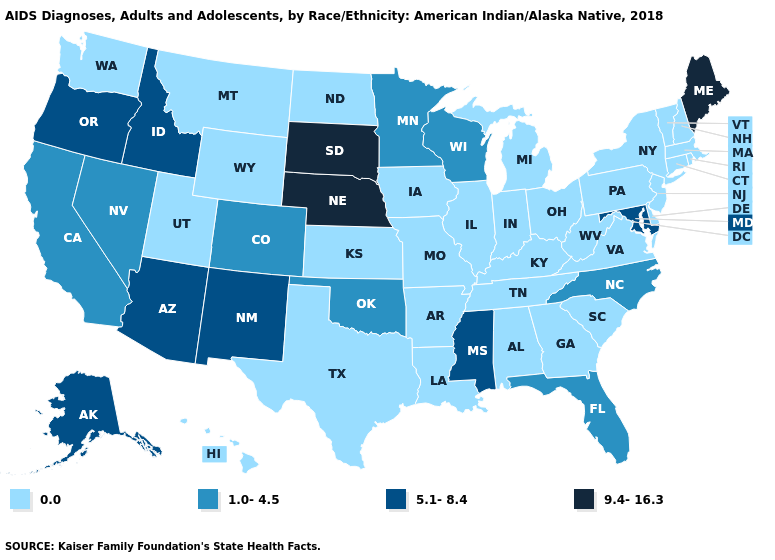Does Maine have the highest value in the USA?
Short answer required. Yes. Name the states that have a value in the range 9.4-16.3?
Answer briefly. Maine, Nebraska, South Dakota. How many symbols are there in the legend?
Give a very brief answer. 4. What is the value of California?
Give a very brief answer. 1.0-4.5. What is the value of Indiana?
Give a very brief answer. 0.0. Which states hav the highest value in the West?
Write a very short answer. Alaska, Arizona, Idaho, New Mexico, Oregon. Name the states that have a value in the range 5.1-8.4?
Give a very brief answer. Alaska, Arizona, Idaho, Maryland, Mississippi, New Mexico, Oregon. Does the first symbol in the legend represent the smallest category?
Be succinct. Yes. What is the value of Utah?
Give a very brief answer. 0.0. How many symbols are there in the legend?
Keep it brief. 4. Does the map have missing data?
Answer briefly. No. How many symbols are there in the legend?
Give a very brief answer. 4. What is the value of New Mexico?
Be succinct. 5.1-8.4. 